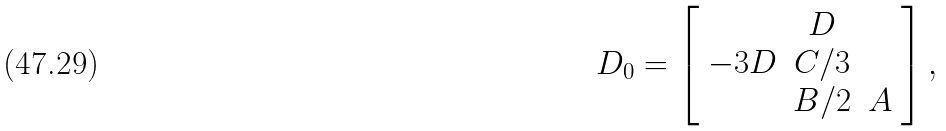<formula> <loc_0><loc_0><loc_500><loc_500>D _ { 0 } = \left [ \begin{array} { c c c } & D & \\ - 3 D & C / 3 & \\ & B / 2 & A \end{array} \right ] ,</formula> 